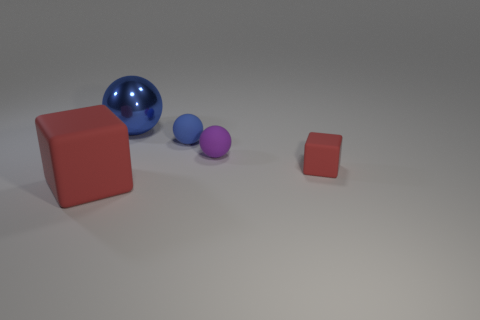Add 1 brown cylinders. How many objects exist? 6 Subtract all balls. How many objects are left? 2 Add 4 blue metal things. How many blue metal things are left? 5 Add 1 blue balls. How many blue balls exist? 3 Subtract 0 gray spheres. How many objects are left? 5 Subtract all small red things. Subtract all red things. How many objects are left? 2 